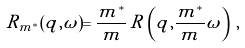<formula> <loc_0><loc_0><loc_500><loc_500>R _ { m ^ { * } } ( q , \omega ) = \frac { m ^ { * } } { m } \, R \left ( q , \frac { m ^ { * } } { m } \omega \right ) \, ,</formula> 